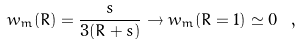<formula> <loc_0><loc_0><loc_500><loc_500>w _ { m } ( R ) = \frac { s } { 3 ( R + s ) } \rightarrow w _ { m } ( R = 1 ) \simeq 0 \ ,</formula> 